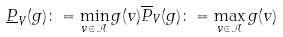<formula> <loc_0><loc_0><loc_500><loc_500>\underline { P } _ { V } ( g ) \colon = \min _ { v \in \mathcal { A } } g ( v ) \overline { P } _ { V } ( g ) \colon = \max _ { v \in \mathcal { A } } g ( v )</formula> 